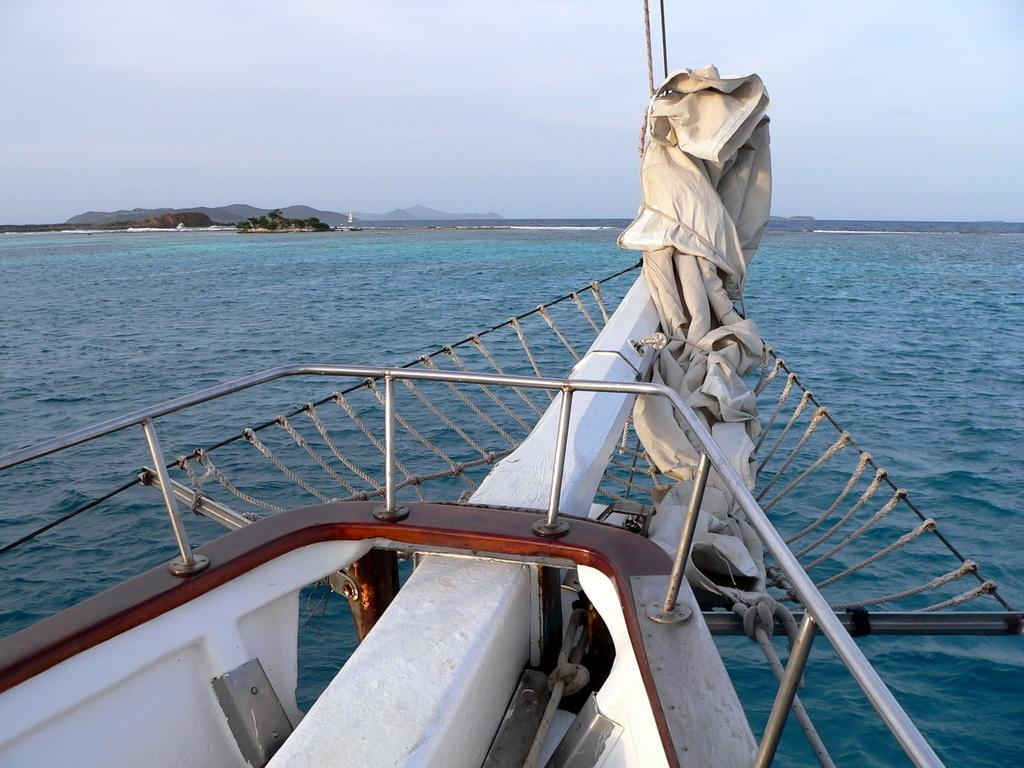What is the main subject of the image? There is a part of a ship in the image. What objects are associated with the ship in the image? There are rods and ropes in the image. What is the setting of the image? There is water, trees, hills, and the sky visible in the background of the image. What type of toothpaste is being used on the ship in the image? There is no toothpaste present in the image; it features a part of a ship with rods and ropes. What time of day is it in the image, given the lighting and shadows? The provided facts do not give enough information to determine the time of day in the image. 